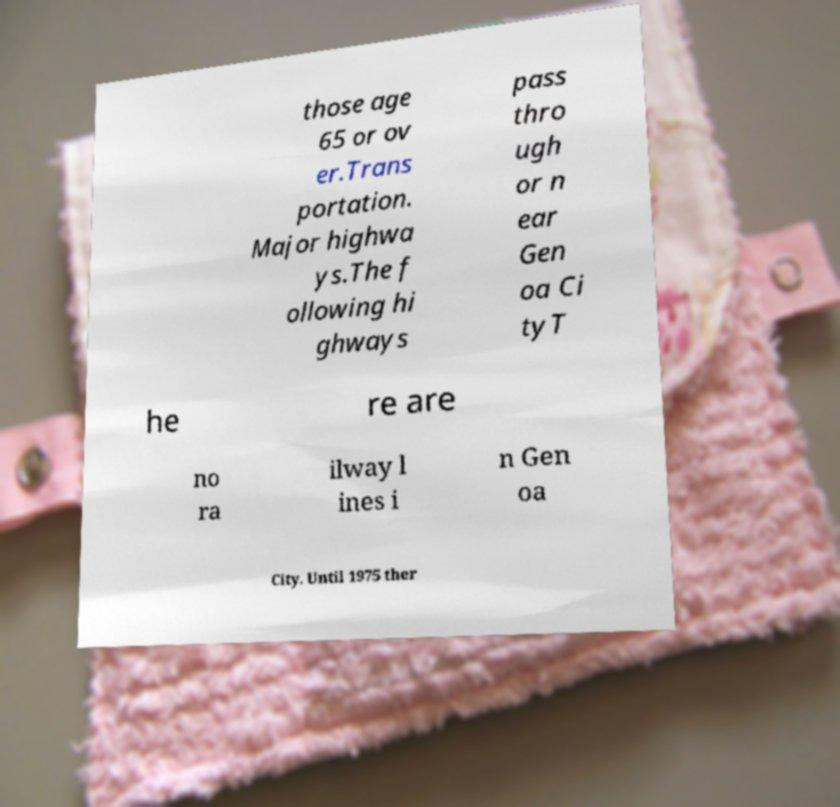I need the written content from this picture converted into text. Can you do that? those age 65 or ov er.Trans portation. Major highwa ys.The f ollowing hi ghways pass thro ugh or n ear Gen oa Ci tyT he re are no ra ilway l ines i n Gen oa City. Until 1975 ther 